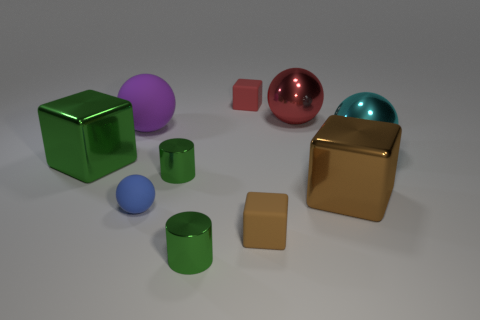Subtract all blocks. How many objects are left? 6 Subtract 0 purple cylinders. How many objects are left? 10 Subtract all large brown metallic things. Subtract all big green cubes. How many objects are left? 8 Add 6 small red things. How many small red things are left? 7 Add 6 small blue objects. How many small blue objects exist? 7 